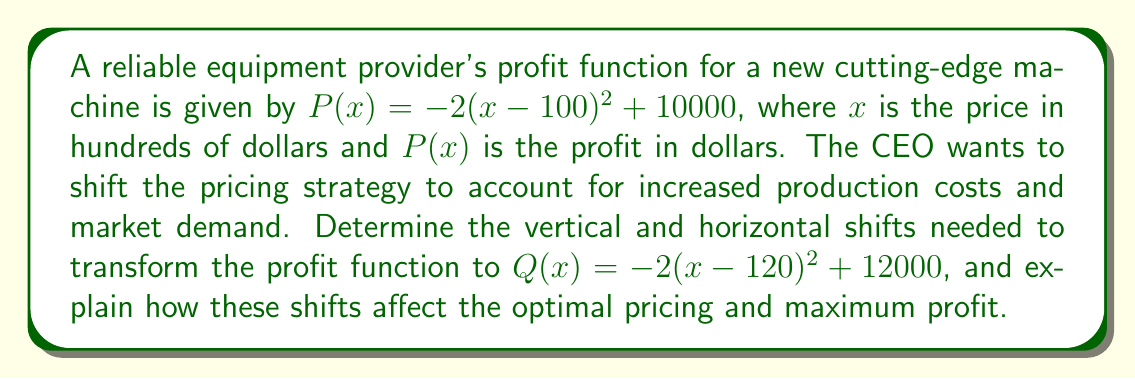Can you answer this question? To solve this problem, we need to compare the original function $P(x)$ with the transformed function $Q(x)$ and identify the vertical and horizontal shifts:

1. Original function: $P(x) = -2(x-100)^2 + 10000$
2. Transformed function: $Q(x) = -2(x-120)^2 + 12000$

Let's analyze the changes:

a) Horizontal shift:
   - In $P(x)$, we have $(x-100)$
   - In $Q(x)$, we have $(x-120)$
   - The horizontal shift is 20 units to the right (positive direction)

b) Vertical shift:
   - In $P(x)$, the constant term is 10000
   - In $Q(x)$, the constant term is 12000
   - The vertical shift is 2000 units upward

To understand how these shifts affect optimal pricing and maximum profit:

1. Optimal pricing:
   - For $P(x)$, the vertex is at $x=100$ (hundreds of dollars), so the optimal price is $10,000
   - For $Q(x)$, the vertex is at $x=120$ (hundreds of dollars), so the new optimal price is $12,000

2. Maximum profit:
   - For $P(x)$, the maximum profit is $10,000 (at the vertex)
   - For $Q(x)$, the maximum profit is $12,000 (at the vertex)

The horizontal shift of 20 units to the right indicates that the optimal price has increased by $2,000. This could be due to increased production costs or higher market demand for the cutting-edge machine.

The vertical shift of 2000 units upward shows that the maximum profit has increased by $2,000. This suggests that despite the higher optimal price, the company can still achieve a higher profit, possibly due to improved market conditions or cost efficiencies in production.
Answer: The horizontal shift is 20 units to the right, and the vertical shift is 2000 units upward. These shifts result in an increase of the optimal price by $2,000 and an increase in maximum profit by $2,000. 